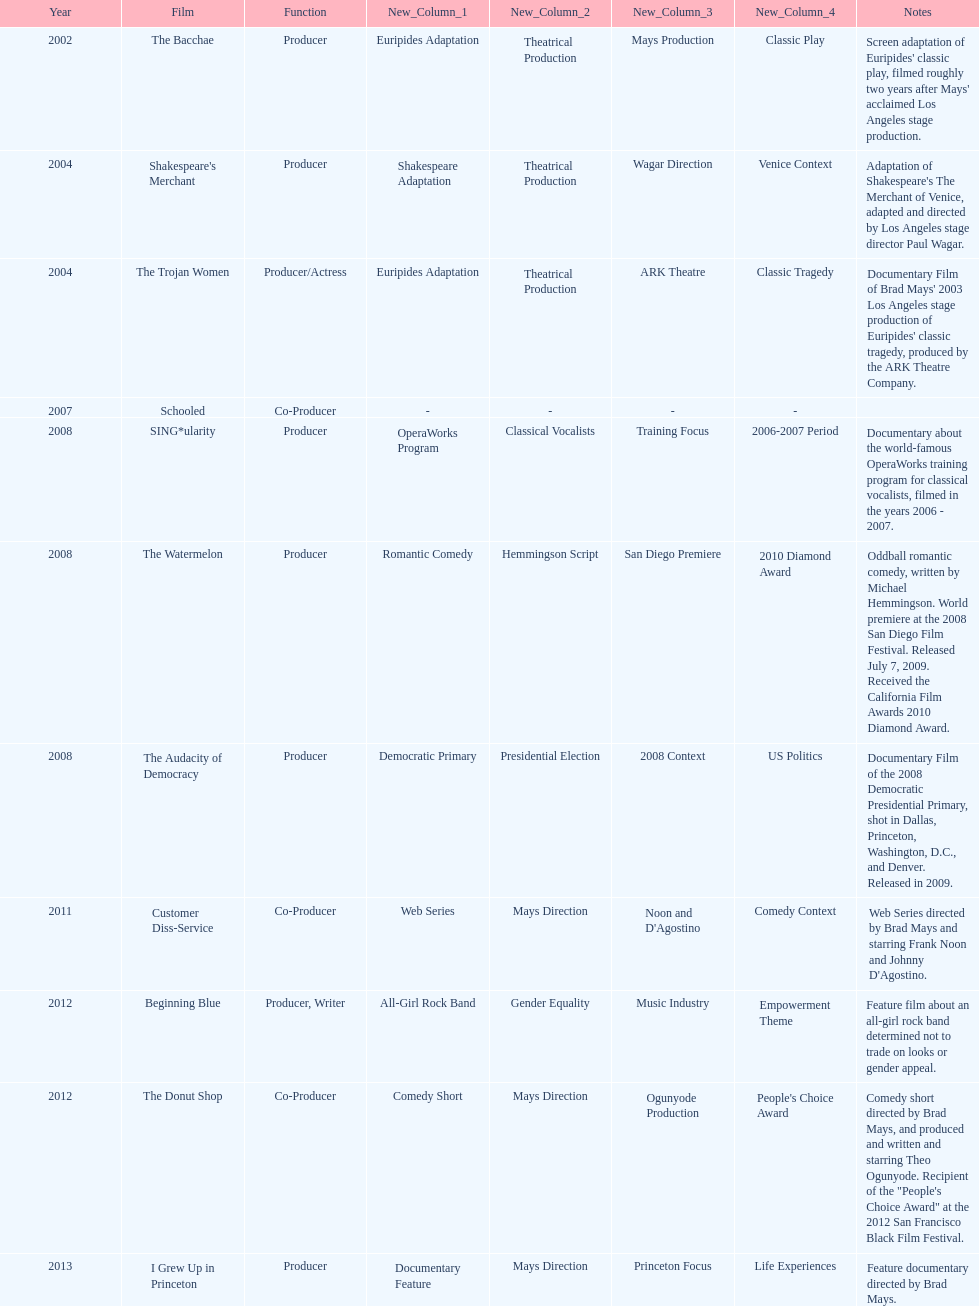In which year did ms. starfelt produce the most films? 2008. 